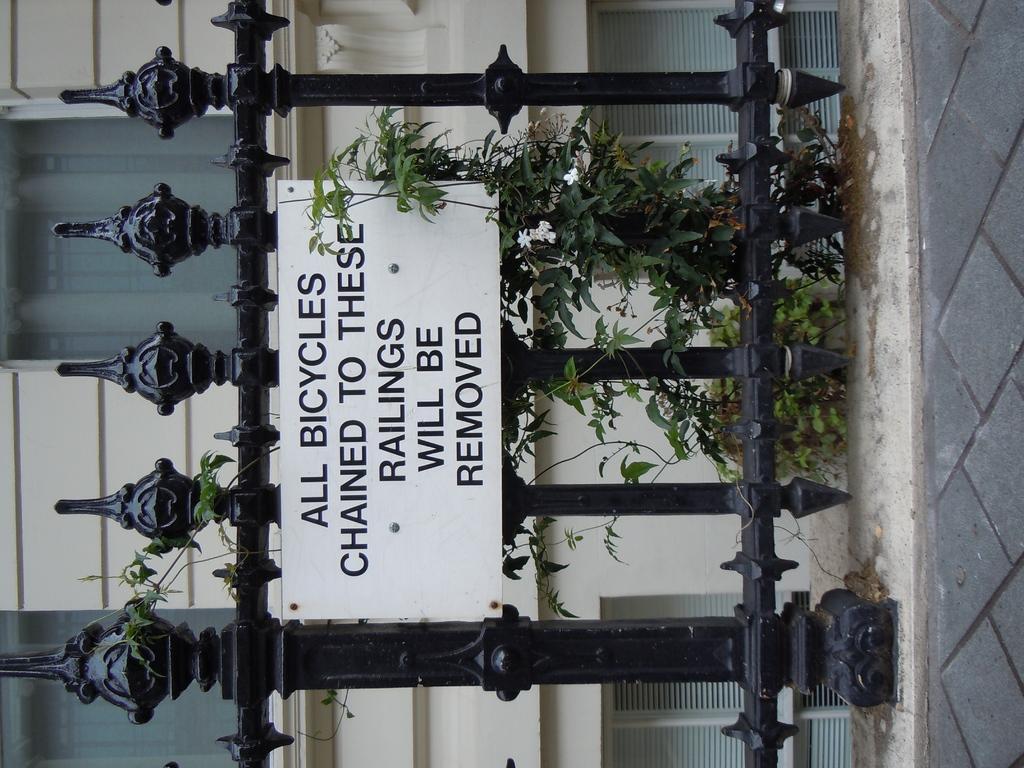In one or two sentences, can you explain what this image depicts? In this image in the center there is one building and some plants, and also in the foreground there is one fence and one board is attached to the fence. On the right side there is a walkway. 